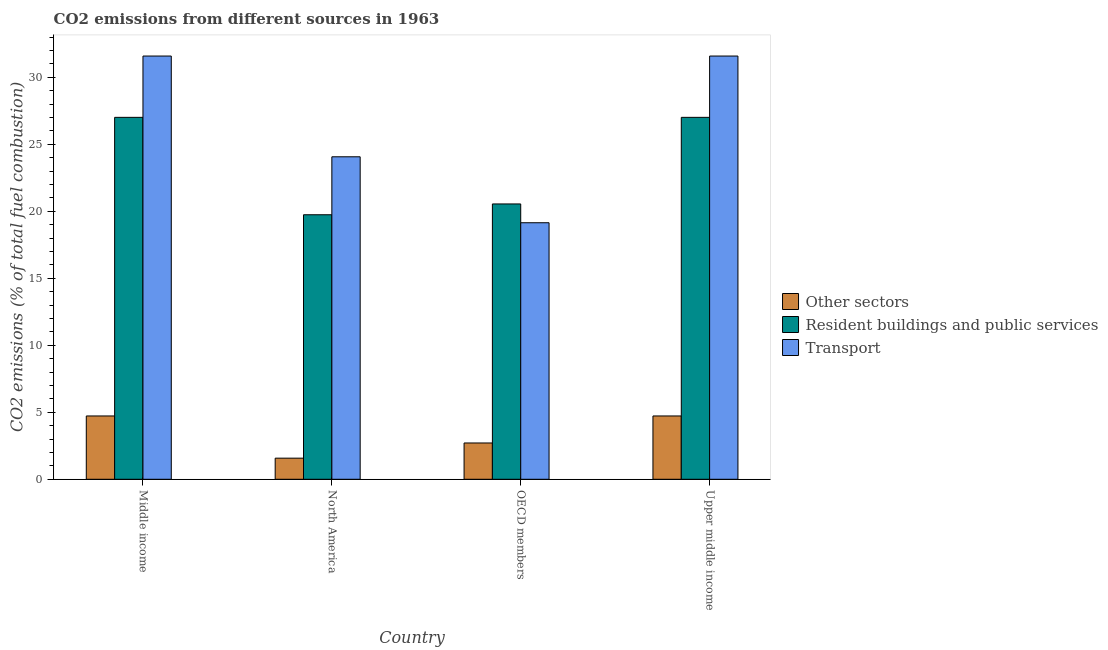How many groups of bars are there?
Your response must be concise. 4. How many bars are there on the 1st tick from the left?
Ensure brevity in your answer.  3. How many bars are there on the 4th tick from the right?
Offer a terse response. 3. What is the label of the 1st group of bars from the left?
Offer a very short reply. Middle income. What is the percentage of co2 emissions from resident buildings and public services in Upper middle income?
Your answer should be very brief. 27.01. Across all countries, what is the maximum percentage of co2 emissions from other sectors?
Your answer should be compact. 4.73. Across all countries, what is the minimum percentage of co2 emissions from resident buildings and public services?
Offer a very short reply. 19.74. In which country was the percentage of co2 emissions from resident buildings and public services maximum?
Your response must be concise. Middle income. What is the total percentage of co2 emissions from resident buildings and public services in the graph?
Ensure brevity in your answer.  94.33. What is the difference between the percentage of co2 emissions from other sectors in North America and that in Upper middle income?
Provide a succinct answer. -3.15. What is the difference between the percentage of co2 emissions from transport in Middle income and the percentage of co2 emissions from other sectors in North America?
Offer a very short reply. 30.02. What is the average percentage of co2 emissions from resident buildings and public services per country?
Make the answer very short. 23.58. What is the difference between the percentage of co2 emissions from resident buildings and public services and percentage of co2 emissions from other sectors in North America?
Make the answer very short. 18.17. What is the ratio of the percentage of co2 emissions from resident buildings and public services in Middle income to that in North America?
Make the answer very short. 1.37. Is the percentage of co2 emissions from resident buildings and public services in North America less than that in OECD members?
Your answer should be compact. Yes. What is the difference between the highest and the lowest percentage of co2 emissions from transport?
Offer a very short reply. 12.44. Is the sum of the percentage of co2 emissions from other sectors in Middle income and North America greater than the maximum percentage of co2 emissions from transport across all countries?
Provide a succinct answer. No. What does the 3rd bar from the left in Upper middle income represents?
Your response must be concise. Transport. What does the 1st bar from the right in Middle income represents?
Offer a terse response. Transport. What is the difference between two consecutive major ticks on the Y-axis?
Provide a short and direct response. 5. Are the values on the major ticks of Y-axis written in scientific E-notation?
Your answer should be very brief. No. Does the graph contain any zero values?
Your answer should be compact. No. Where does the legend appear in the graph?
Provide a short and direct response. Center right. How many legend labels are there?
Provide a short and direct response. 3. How are the legend labels stacked?
Your answer should be compact. Vertical. What is the title of the graph?
Offer a very short reply. CO2 emissions from different sources in 1963. Does "Manufactures" appear as one of the legend labels in the graph?
Provide a succinct answer. No. What is the label or title of the Y-axis?
Give a very brief answer. CO2 emissions (% of total fuel combustion). What is the CO2 emissions (% of total fuel combustion) of Other sectors in Middle income?
Your answer should be compact. 4.73. What is the CO2 emissions (% of total fuel combustion) in Resident buildings and public services in Middle income?
Provide a short and direct response. 27.01. What is the CO2 emissions (% of total fuel combustion) in Transport in Middle income?
Your answer should be very brief. 31.59. What is the CO2 emissions (% of total fuel combustion) in Other sectors in North America?
Offer a terse response. 1.58. What is the CO2 emissions (% of total fuel combustion) in Resident buildings and public services in North America?
Offer a very short reply. 19.74. What is the CO2 emissions (% of total fuel combustion) in Transport in North America?
Provide a short and direct response. 24.07. What is the CO2 emissions (% of total fuel combustion) of Other sectors in OECD members?
Your answer should be compact. 2.71. What is the CO2 emissions (% of total fuel combustion) in Resident buildings and public services in OECD members?
Give a very brief answer. 20.55. What is the CO2 emissions (% of total fuel combustion) of Transport in OECD members?
Offer a very short reply. 19.15. What is the CO2 emissions (% of total fuel combustion) in Other sectors in Upper middle income?
Give a very brief answer. 4.73. What is the CO2 emissions (% of total fuel combustion) in Resident buildings and public services in Upper middle income?
Provide a short and direct response. 27.01. What is the CO2 emissions (% of total fuel combustion) in Transport in Upper middle income?
Your answer should be very brief. 31.59. Across all countries, what is the maximum CO2 emissions (% of total fuel combustion) of Other sectors?
Offer a very short reply. 4.73. Across all countries, what is the maximum CO2 emissions (% of total fuel combustion) of Resident buildings and public services?
Your response must be concise. 27.01. Across all countries, what is the maximum CO2 emissions (% of total fuel combustion) of Transport?
Offer a terse response. 31.59. Across all countries, what is the minimum CO2 emissions (% of total fuel combustion) in Other sectors?
Your answer should be compact. 1.58. Across all countries, what is the minimum CO2 emissions (% of total fuel combustion) in Resident buildings and public services?
Provide a succinct answer. 19.74. Across all countries, what is the minimum CO2 emissions (% of total fuel combustion) in Transport?
Keep it short and to the point. 19.15. What is the total CO2 emissions (% of total fuel combustion) of Other sectors in the graph?
Provide a succinct answer. 13.74. What is the total CO2 emissions (% of total fuel combustion) of Resident buildings and public services in the graph?
Offer a very short reply. 94.33. What is the total CO2 emissions (% of total fuel combustion) in Transport in the graph?
Make the answer very short. 106.4. What is the difference between the CO2 emissions (% of total fuel combustion) in Other sectors in Middle income and that in North America?
Make the answer very short. 3.15. What is the difference between the CO2 emissions (% of total fuel combustion) in Resident buildings and public services in Middle income and that in North America?
Provide a succinct answer. 7.27. What is the difference between the CO2 emissions (% of total fuel combustion) of Transport in Middle income and that in North America?
Provide a succinct answer. 7.52. What is the difference between the CO2 emissions (% of total fuel combustion) of Other sectors in Middle income and that in OECD members?
Offer a terse response. 2.02. What is the difference between the CO2 emissions (% of total fuel combustion) of Resident buildings and public services in Middle income and that in OECD members?
Provide a short and direct response. 6.46. What is the difference between the CO2 emissions (% of total fuel combustion) in Transport in Middle income and that in OECD members?
Ensure brevity in your answer.  12.44. What is the difference between the CO2 emissions (% of total fuel combustion) of Resident buildings and public services in Middle income and that in Upper middle income?
Give a very brief answer. 0. What is the difference between the CO2 emissions (% of total fuel combustion) in Other sectors in North America and that in OECD members?
Make the answer very short. -1.13. What is the difference between the CO2 emissions (% of total fuel combustion) in Resident buildings and public services in North America and that in OECD members?
Ensure brevity in your answer.  -0.81. What is the difference between the CO2 emissions (% of total fuel combustion) of Transport in North America and that in OECD members?
Provide a succinct answer. 4.92. What is the difference between the CO2 emissions (% of total fuel combustion) of Other sectors in North America and that in Upper middle income?
Offer a very short reply. -3.15. What is the difference between the CO2 emissions (% of total fuel combustion) in Resident buildings and public services in North America and that in Upper middle income?
Keep it short and to the point. -7.27. What is the difference between the CO2 emissions (% of total fuel combustion) of Transport in North America and that in Upper middle income?
Make the answer very short. -7.52. What is the difference between the CO2 emissions (% of total fuel combustion) of Other sectors in OECD members and that in Upper middle income?
Make the answer very short. -2.02. What is the difference between the CO2 emissions (% of total fuel combustion) in Resident buildings and public services in OECD members and that in Upper middle income?
Offer a terse response. -6.46. What is the difference between the CO2 emissions (% of total fuel combustion) in Transport in OECD members and that in Upper middle income?
Offer a very short reply. -12.44. What is the difference between the CO2 emissions (% of total fuel combustion) in Other sectors in Middle income and the CO2 emissions (% of total fuel combustion) in Resident buildings and public services in North America?
Ensure brevity in your answer.  -15.02. What is the difference between the CO2 emissions (% of total fuel combustion) of Other sectors in Middle income and the CO2 emissions (% of total fuel combustion) of Transport in North America?
Your answer should be compact. -19.35. What is the difference between the CO2 emissions (% of total fuel combustion) of Resident buildings and public services in Middle income and the CO2 emissions (% of total fuel combustion) of Transport in North America?
Provide a succinct answer. 2.94. What is the difference between the CO2 emissions (% of total fuel combustion) in Other sectors in Middle income and the CO2 emissions (% of total fuel combustion) in Resident buildings and public services in OECD members?
Ensure brevity in your answer.  -15.83. What is the difference between the CO2 emissions (% of total fuel combustion) in Other sectors in Middle income and the CO2 emissions (% of total fuel combustion) in Transport in OECD members?
Provide a short and direct response. -14.42. What is the difference between the CO2 emissions (% of total fuel combustion) of Resident buildings and public services in Middle income and the CO2 emissions (% of total fuel combustion) of Transport in OECD members?
Your answer should be compact. 7.87. What is the difference between the CO2 emissions (% of total fuel combustion) of Other sectors in Middle income and the CO2 emissions (% of total fuel combustion) of Resident buildings and public services in Upper middle income?
Make the answer very short. -22.29. What is the difference between the CO2 emissions (% of total fuel combustion) of Other sectors in Middle income and the CO2 emissions (% of total fuel combustion) of Transport in Upper middle income?
Make the answer very short. -26.87. What is the difference between the CO2 emissions (% of total fuel combustion) of Resident buildings and public services in Middle income and the CO2 emissions (% of total fuel combustion) of Transport in Upper middle income?
Provide a succinct answer. -4.58. What is the difference between the CO2 emissions (% of total fuel combustion) in Other sectors in North America and the CO2 emissions (% of total fuel combustion) in Resident buildings and public services in OECD members?
Offer a terse response. -18.98. What is the difference between the CO2 emissions (% of total fuel combustion) in Other sectors in North America and the CO2 emissions (% of total fuel combustion) in Transport in OECD members?
Provide a short and direct response. -17.57. What is the difference between the CO2 emissions (% of total fuel combustion) in Resident buildings and public services in North America and the CO2 emissions (% of total fuel combustion) in Transport in OECD members?
Your answer should be compact. 0.6. What is the difference between the CO2 emissions (% of total fuel combustion) in Other sectors in North America and the CO2 emissions (% of total fuel combustion) in Resident buildings and public services in Upper middle income?
Ensure brevity in your answer.  -25.44. What is the difference between the CO2 emissions (% of total fuel combustion) in Other sectors in North America and the CO2 emissions (% of total fuel combustion) in Transport in Upper middle income?
Your answer should be very brief. -30.02. What is the difference between the CO2 emissions (% of total fuel combustion) of Resident buildings and public services in North America and the CO2 emissions (% of total fuel combustion) of Transport in Upper middle income?
Give a very brief answer. -11.85. What is the difference between the CO2 emissions (% of total fuel combustion) in Other sectors in OECD members and the CO2 emissions (% of total fuel combustion) in Resident buildings and public services in Upper middle income?
Give a very brief answer. -24.31. What is the difference between the CO2 emissions (% of total fuel combustion) in Other sectors in OECD members and the CO2 emissions (% of total fuel combustion) in Transport in Upper middle income?
Make the answer very short. -28.88. What is the difference between the CO2 emissions (% of total fuel combustion) in Resident buildings and public services in OECD members and the CO2 emissions (% of total fuel combustion) in Transport in Upper middle income?
Ensure brevity in your answer.  -11.04. What is the average CO2 emissions (% of total fuel combustion) in Other sectors per country?
Your answer should be very brief. 3.43. What is the average CO2 emissions (% of total fuel combustion) in Resident buildings and public services per country?
Provide a succinct answer. 23.58. What is the average CO2 emissions (% of total fuel combustion) in Transport per country?
Your answer should be compact. 26.6. What is the difference between the CO2 emissions (% of total fuel combustion) of Other sectors and CO2 emissions (% of total fuel combustion) of Resident buildings and public services in Middle income?
Give a very brief answer. -22.29. What is the difference between the CO2 emissions (% of total fuel combustion) in Other sectors and CO2 emissions (% of total fuel combustion) in Transport in Middle income?
Your answer should be compact. -26.87. What is the difference between the CO2 emissions (% of total fuel combustion) in Resident buildings and public services and CO2 emissions (% of total fuel combustion) in Transport in Middle income?
Make the answer very short. -4.58. What is the difference between the CO2 emissions (% of total fuel combustion) in Other sectors and CO2 emissions (% of total fuel combustion) in Resident buildings and public services in North America?
Your response must be concise. -18.17. What is the difference between the CO2 emissions (% of total fuel combustion) of Other sectors and CO2 emissions (% of total fuel combustion) of Transport in North America?
Give a very brief answer. -22.5. What is the difference between the CO2 emissions (% of total fuel combustion) of Resident buildings and public services and CO2 emissions (% of total fuel combustion) of Transport in North America?
Ensure brevity in your answer.  -4.33. What is the difference between the CO2 emissions (% of total fuel combustion) of Other sectors and CO2 emissions (% of total fuel combustion) of Resident buildings and public services in OECD members?
Offer a terse response. -17.84. What is the difference between the CO2 emissions (% of total fuel combustion) in Other sectors and CO2 emissions (% of total fuel combustion) in Transport in OECD members?
Provide a short and direct response. -16.44. What is the difference between the CO2 emissions (% of total fuel combustion) of Resident buildings and public services and CO2 emissions (% of total fuel combustion) of Transport in OECD members?
Give a very brief answer. 1.4. What is the difference between the CO2 emissions (% of total fuel combustion) of Other sectors and CO2 emissions (% of total fuel combustion) of Resident buildings and public services in Upper middle income?
Provide a succinct answer. -22.29. What is the difference between the CO2 emissions (% of total fuel combustion) in Other sectors and CO2 emissions (% of total fuel combustion) in Transport in Upper middle income?
Your response must be concise. -26.87. What is the difference between the CO2 emissions (% of total fuel combustion) of Resident buildings and public services and CO2 emissions (% of total fuel combustion) of Transport in Upper middle income?
Ensure brevity in your answer.  -4.58. What is the ratio of the CO2 emissions (% of total fuel combustion) in Other sectors in Middle income to that in North America?
Make the answer very short. 3. What is the ratio of the CO2 emissions (% of total fuel combustion) of Resident buildings and public services in Middle income to that in North America?
Provide a succinct answer. 1.37. What is the ratio of the CO2 emissions (% of total fuel combustion) of Transport in Middle income to that in North America?
Your answer should be very brief. 1.31. What is the ratio of the CO2 emissions (% of total fuel combustion) in Other sectors in Middle income to that in OECD members?
Make the answer very short. 1.74. What is the ratio of the CO2 emissions (% of total fuel combustion) of Resident buildings and public services in Middle income to that in OECD members?
Provide a short and direct response. 1.31. What is the ratio of the CO2 emissions (% of total fuel combustion) of Transport in Middle income to that in OECD members?
Ensure brevity in your answer.  1.65. What is the ratio of the CO2 emissions (% of total fuel combustion) of Other sectors in North America to that in OECD members?
Offer a very short reply. 0.58. What is the ratio of the CO2 emissions (% of total fuel combustion) in Resident buildings and public services in North America to that in OECD members?
Give a very brief answer. 0.96. What is the ratio of the CO2 emissions (% of total fuel combustion) of Transport in North America to that in OECD members?
Ensure brevity in your answer.  1.26. What is the ratio of the CO2 emissions (% of total fuel combustion) of Other sectors in North America to that in Upper middle income?
Offer a terse response. 0.33. What is the ratio of the CO2 emissions (% of total fuel combustion) of Resident buildings and public services in North America to that in Upper middle income?
Ensure brevity in your answer.  0.73. What is the ratio of the CO2 emissions (% of total fuel combustion) in Transport in North America to that in Upper middle income?
Offer a very short reply. 0.76. What is the ratio of the CO2 emissions (% of total fuel combustion) in Other sectors in OECD members to that in Upper middle income?
Offer a terse response. 0.57. What is the ratio of the CO2 emissions (% of total fuel combustion) in Resident buildings and public services in OECD members to that in Upper middle income?
Give a very brief answer. 0.76. What is the ratio of the CO2 emissions (% of total fuel combustion) in Transport in OECD members to that in Upper middle income?
Provide a short and direct response. 0.61. What is the difference between the highest and the second highest CO2 emissions (% of total fuel combustion) of Other sectors?
Your answer should be compact. 0. What is the difference between the highest and the second highest CO2 emissions (% of total fuel combustion) of Resident buildings and public services?
Keep it short and to the point. 0. What is the difference between the highest and the second highest CO2 emissions (% of total fuel combustion) in Transport?
Offer a very short reply. 0. What is the difference between the highest and the lowest CO2 emissions (% of total fuel combustion) in Other sectors?
Your answer should be compact. 3.15. What is the difference between the highest and the lowest CO2 emissions (% of total fuel combustion) of Resident buildings and public services?
Make the answer very short. 7.27. What is the difference between the highest and the lowest CO2 emissions (% of total fuel combustion) of Transport?
Offer a very short reply. 12.44. 